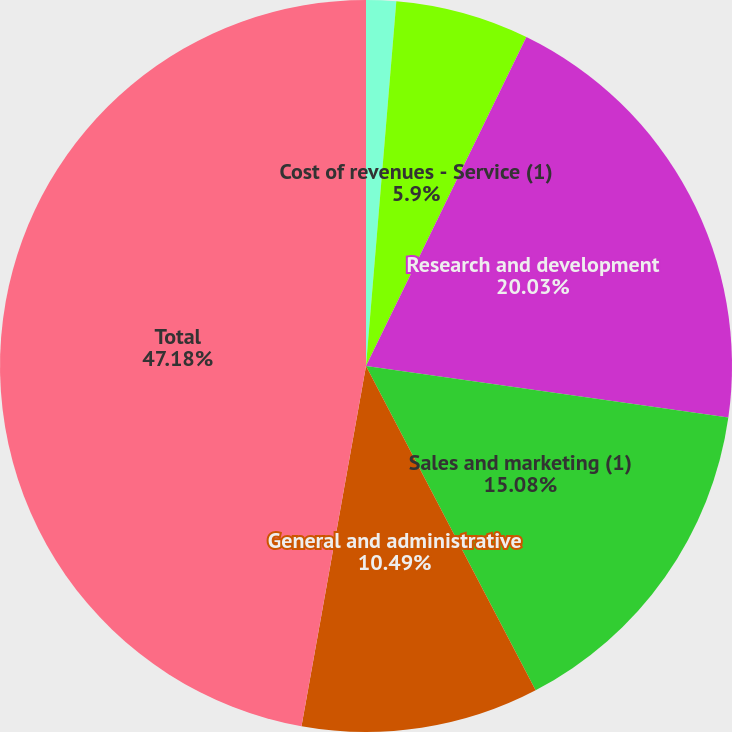Convert chart. <chart><loc_0><loc_0><loc_500><loc_500><pie_chart><fcel>Cost of revenues - Product<fcel>Cost of revenues - Service (1)<fcel>Research and development<fcel>Sales and marketing (1)<fcel>General and administrative<fcel>Total<nl><fcel>1.32%<fcel>5.9%<fcel>20.03%<fcel>15.08%<fcel>10.49%<fcel>47.18%<nl></chart> 